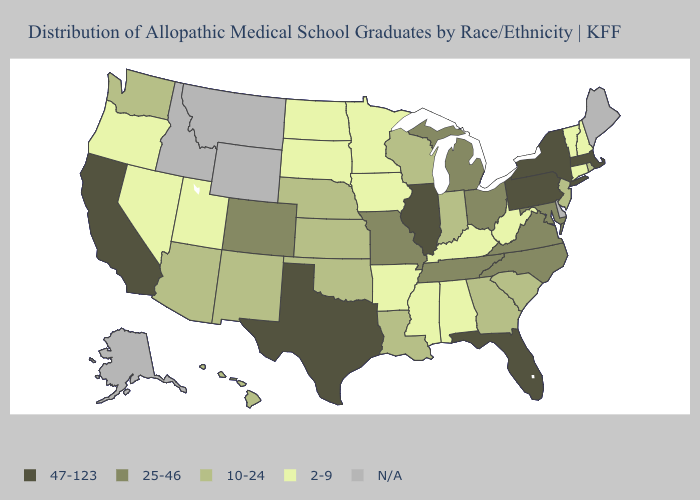Among the states that border Idaho , which have the highest value?
Keep it brief. Washington. Does New Hampshire have the highest value in the Northeast?
Concise answer only. No. What is the lowest value in the USA?
Concise answer only. 2-9. Name the states that have a value in the range 10-24?
Short answer required. Arizona, Georgia, Hawaii, Indiana, Kansas, Louisiana, Nebraska, New Jersey, New Mexico, Oklahoma, Rhode Island, South Carolina, Washington, Wisconsin. What is the value of Arkansas?
Quick response, please. 2-9. What is the lowest value in the South?
Give a very brief answer. 2-9. What is the value of New Hampshire?
Write a very short answer. 2-9. Name the states that have a value in the range 2-9?
Give a very brief answer. Alabama, Arkansas, Connecticut, Iowa, Kentucky, Minnesota, Mississippi, Nevada, New Hampshire, North Dakota, Oregon, South Dakota, Utah, Vermont, West Virginia. Which states have the lowest value in the USA?
Keep it brief. Alabama, Arkansas, Connecticut, Iowa, Kentucky, Minnesota, Mississippi, Nevada, New Hampshire, North Dakota, Oregon, South Dakota, Utah, Vermont, West Virginia. Does North Dakota have the highest value in the USA?
Write a very short answer. No. Among the states that border Louisiana , which have the highest value?
Give a very brief answer. Texas. What is the highest value in the Northeast ?
Quick response, please. 47-123. Among the states that border Virginia , does Tennessee have the highest value?
Write a very short answer. Yes. What is the highest value in states that border Arizona?
Give a very brief answer. 47-123. 